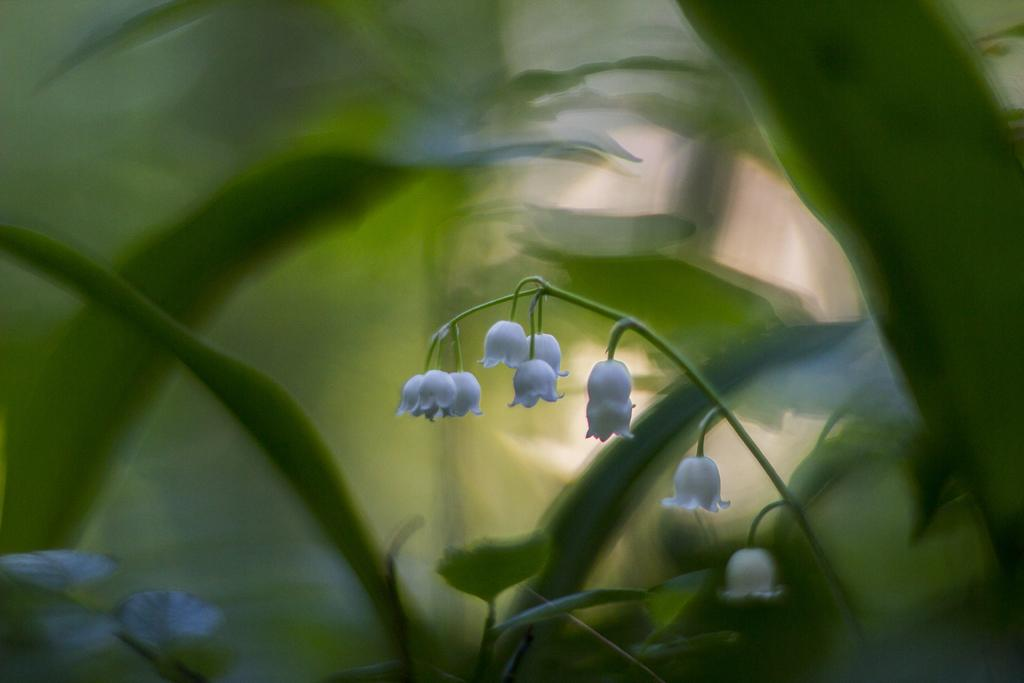What is the main subject in the center of the image? There are flowers in the center of the image. What color are the flowers? The flowers are white in color. What else can be seen at the bottom of the image? There are plants at the bottom of the image. What type of soap is being used to clean the rail in the image? There is no soap or rail present in the image; it features flowers and plants. 